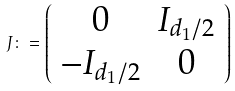Convert formula to latex. <formula><loc_0><loc_0><loc_500><loc_500>J \colon = \left ( \begin{array} { c c } 0 & I _ { d _ { 1 } / 2 } \\ - I _ { d _ { 1 } / 2 } & 0 \end{array} \right )</formula> 